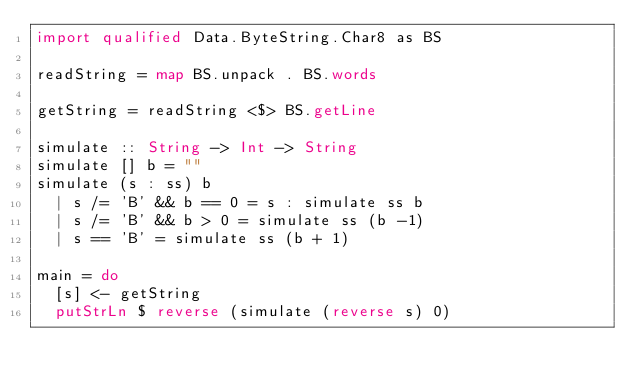Convert code to text. <code><loc_0><loc_0><loc_500><loc_500><_Haskell_>import qualified Data.ByteString.Char8 as BS

readString = map BS.unpack . BS.words

getString = readString <$> BS.getLine

simulate :: String -> Int -> String
simulate [] b = ""
simulate (s : ss) b
  | s /= 'B' && b == 0 = s : simulate ss b
  | s /= 'B' && b > 0 = simulate ss (b -1)
  | s == 'B' = simulate ss (b + 1)

main = do
  [s] <- getString
  putStrLn $ reverse (simulate (reverse s) 0)
</code> 